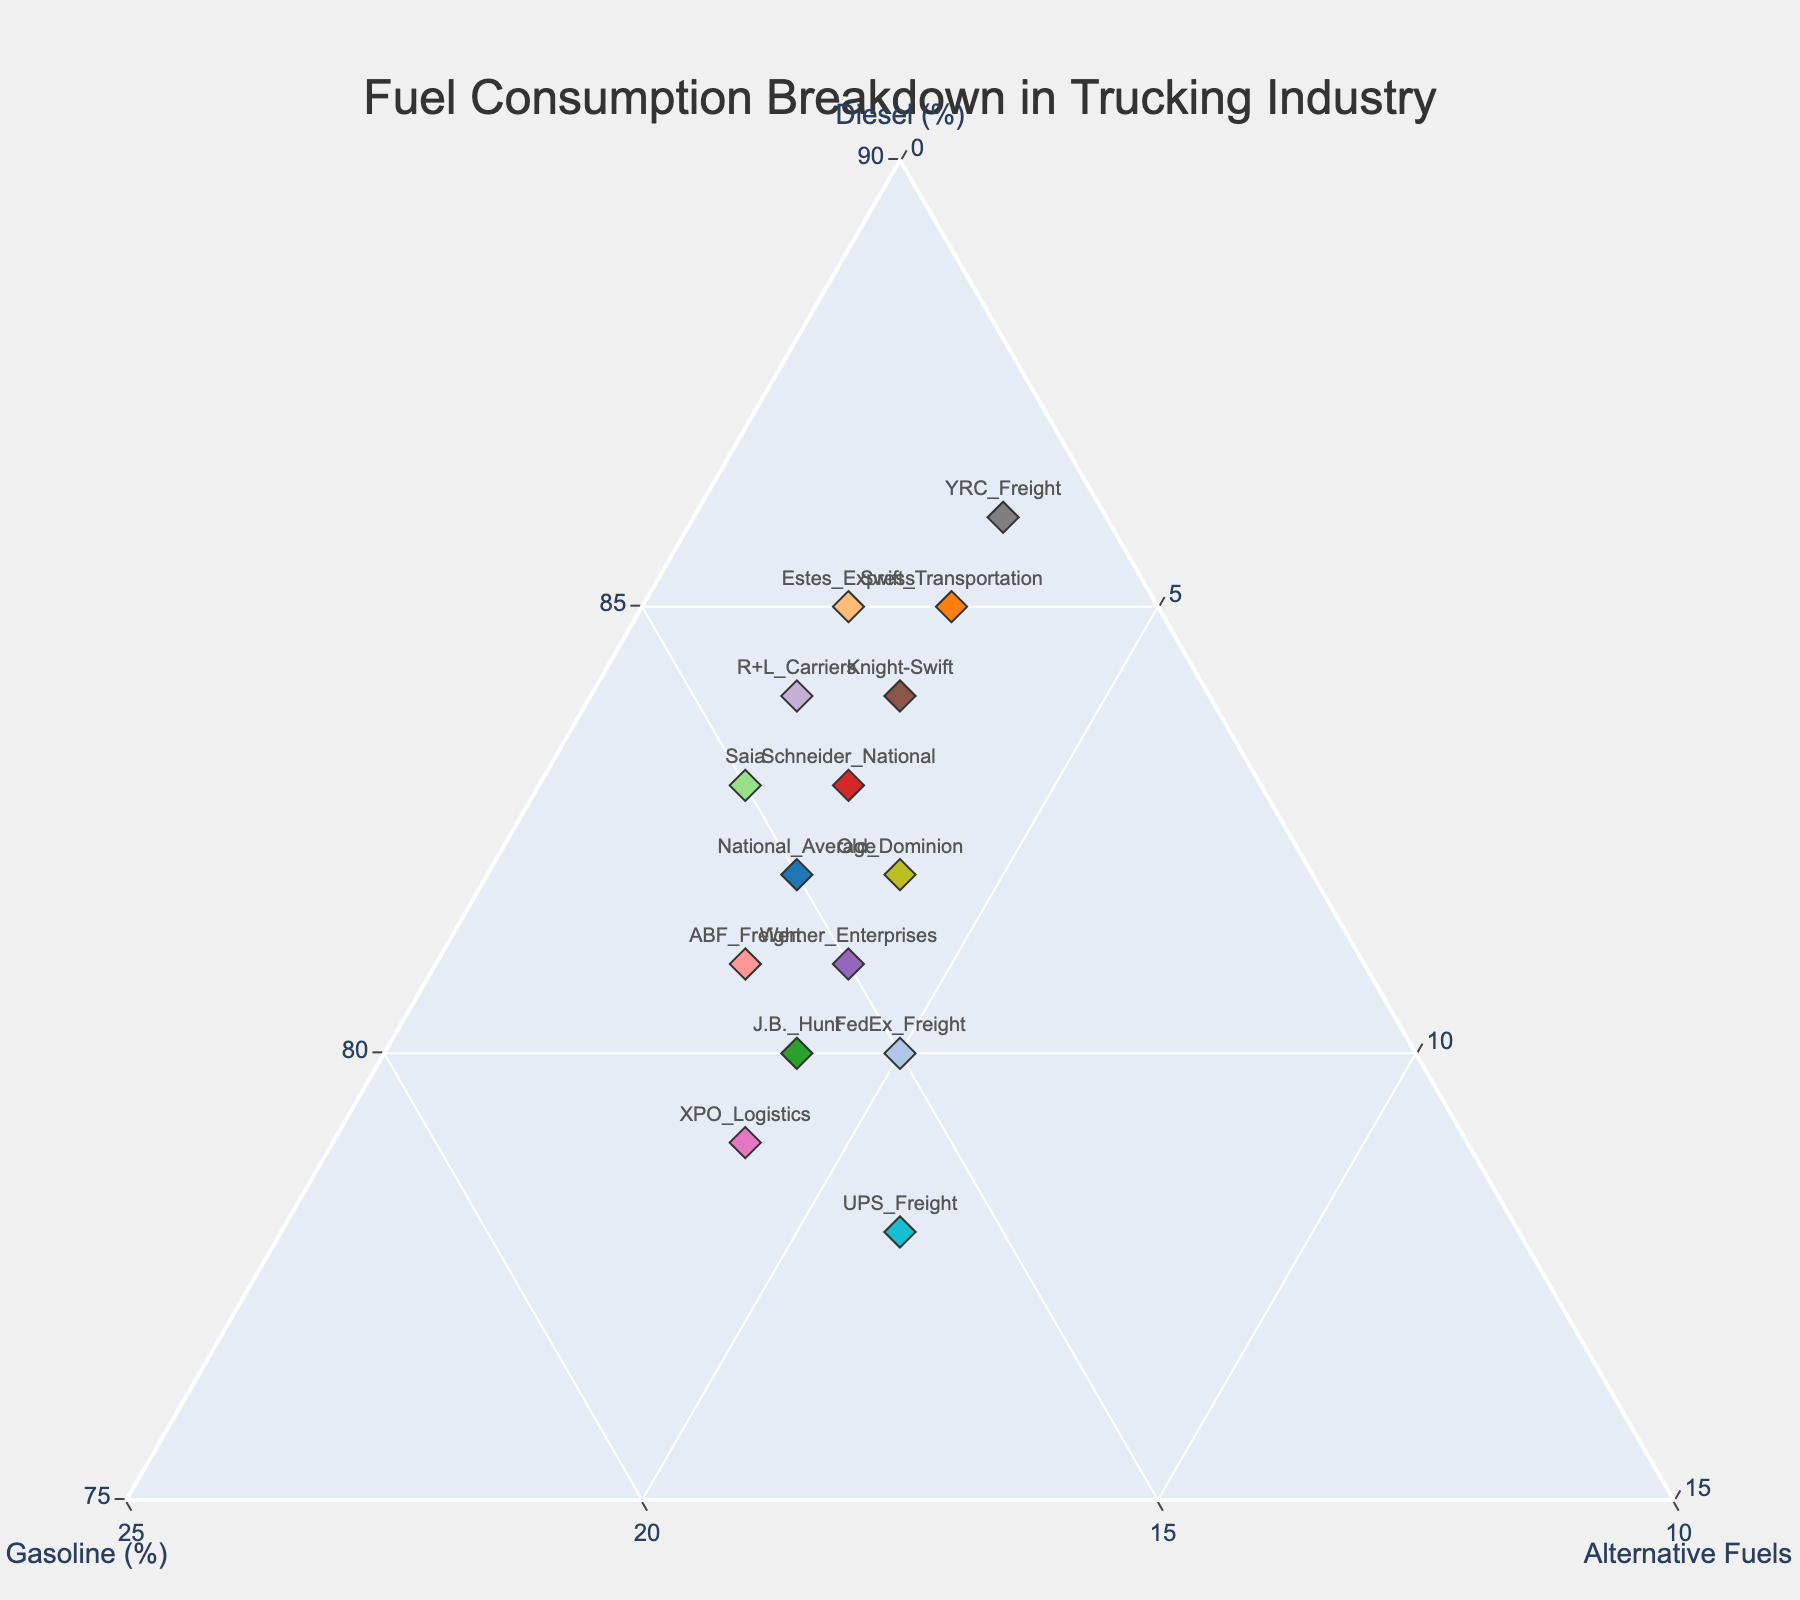what's the title of the plot? The title of the plot is located at the top, typically centered. In this case, it reads "Fuel Consumption Breakdown in Trucking Industry" which summarizes the overall topic of the plot.
Answer: Fuel Consumption Breakdown in Trucking Industry how many data points are shown in the plot? To determine the number of data points, count the individual markers representing each company on the ternary plot. Each marker corresponds to one data point. The provided data includes 15 trucking companies.
Answer: 15 which company has the highest proportion of diesel consumption? Identify the company located closest to the 'Diesel (%)' axis. YRC Freight is positioned at 86% diesel consumption, which is the highest among the listed companies.
Answer: YRC Freight where should a company be on the plot if it uses exactly 50% diesel, 30% gasoline, and 20% alternative fuels? For a company with 50% diesel, 30% gasoline, and 20% alternative fuels, calculate the coordinates on the ternary plot using these proportions. Since the plot measures total proportions adding up to 100%, this company should be located at the point (50, 30, 20) on the plot, corresponding to those specific percentages.
Answer: (50, 30, 20) which two companies rely equally on gasoline? Compare the markers' positions along the 'Gasoline (%)' axis. Both ABF Freight and XPO Logistics are at 16% gasoline consumption.
Answer: ABF Freight and XPO Logistics is there any company with more alternative fuel usage than gasoline usage? Check each company's position in relation to the 'Gasoline (%)' and 'Alternative Fuels (%)' axes. Looking at the plot, UPS Freight is the only company with more alternative fuel usage (6%) than gasoline usage (4%).
Answer: UPS Freight how does Swift Transportation's fuel consumption compare with the national average in terms of diesel and alternative fuels? Swift Transportation has 3% more diesel and the same percentage of alternative fuels compared to the national average (85% diesel and 3% alternative fuels versus 82% diesel and 3% alternative fuels).
Answer: 3% more diesel, same alternative fuels which company uses the least gasoline, and how much is it? Identify the company closest to the point where the 'Gasoline (%)' axis starts. YRC Freight uses the least gasoline, with 11%.
Answer: YRC Freight, 11% if a company wanted to switch entirely to alternative fuels, where would it be on the plot? A company using 100% alternative fuels would be positioned at the bottom vertex of the ternary plot, where the intersection represents 100% alternative fuels and 0% for both diesel and gasoline.
Answer: Bottom vertex (0, 0, 100) what is the average diesel consumption percentage across all companies? Sum all the diesel percentages and divide by the number of companies. Diesel percentages provided are: 82, 85, 80, 83, 81, 84, 79, 86, 82, 78, 80, 85, 83, 81, 84. The total sum is 1233, and dividing by 15 yields an average of 82.2%.
Answer: 82.2% 